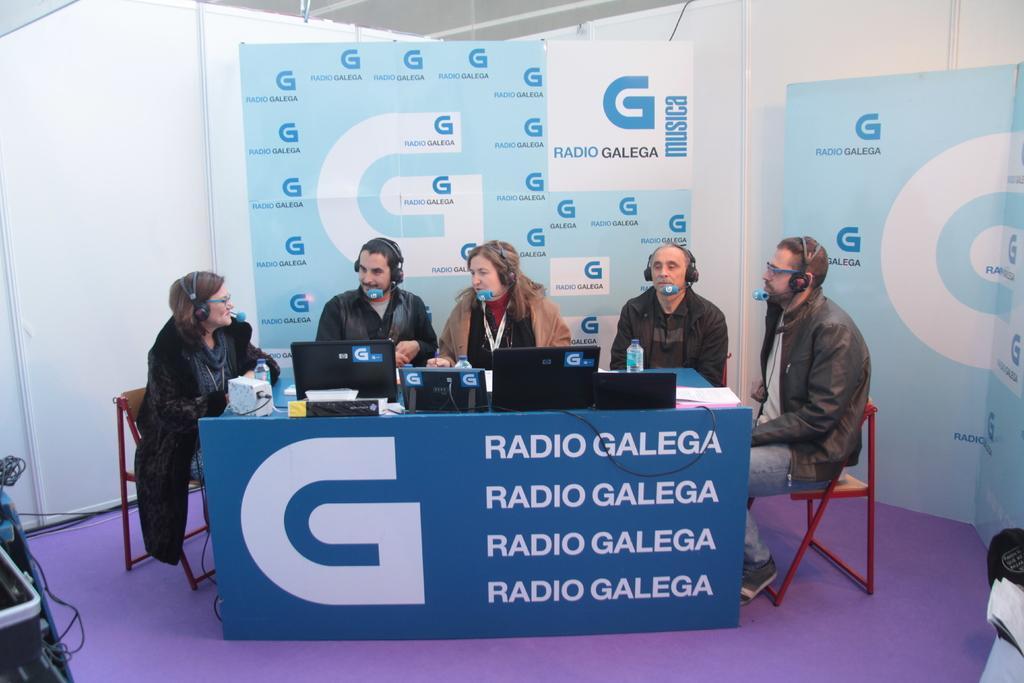How would you summarize this image in a sentence or two? image we can see 5 peoples are sat on the chair. Here we can see board, laptops, paper, bottle, wire. At the background, we can see banners. Right side banner. There is a blue color floor. On left side, we can see some machine. The 5 peoples are wear a headphones.. 